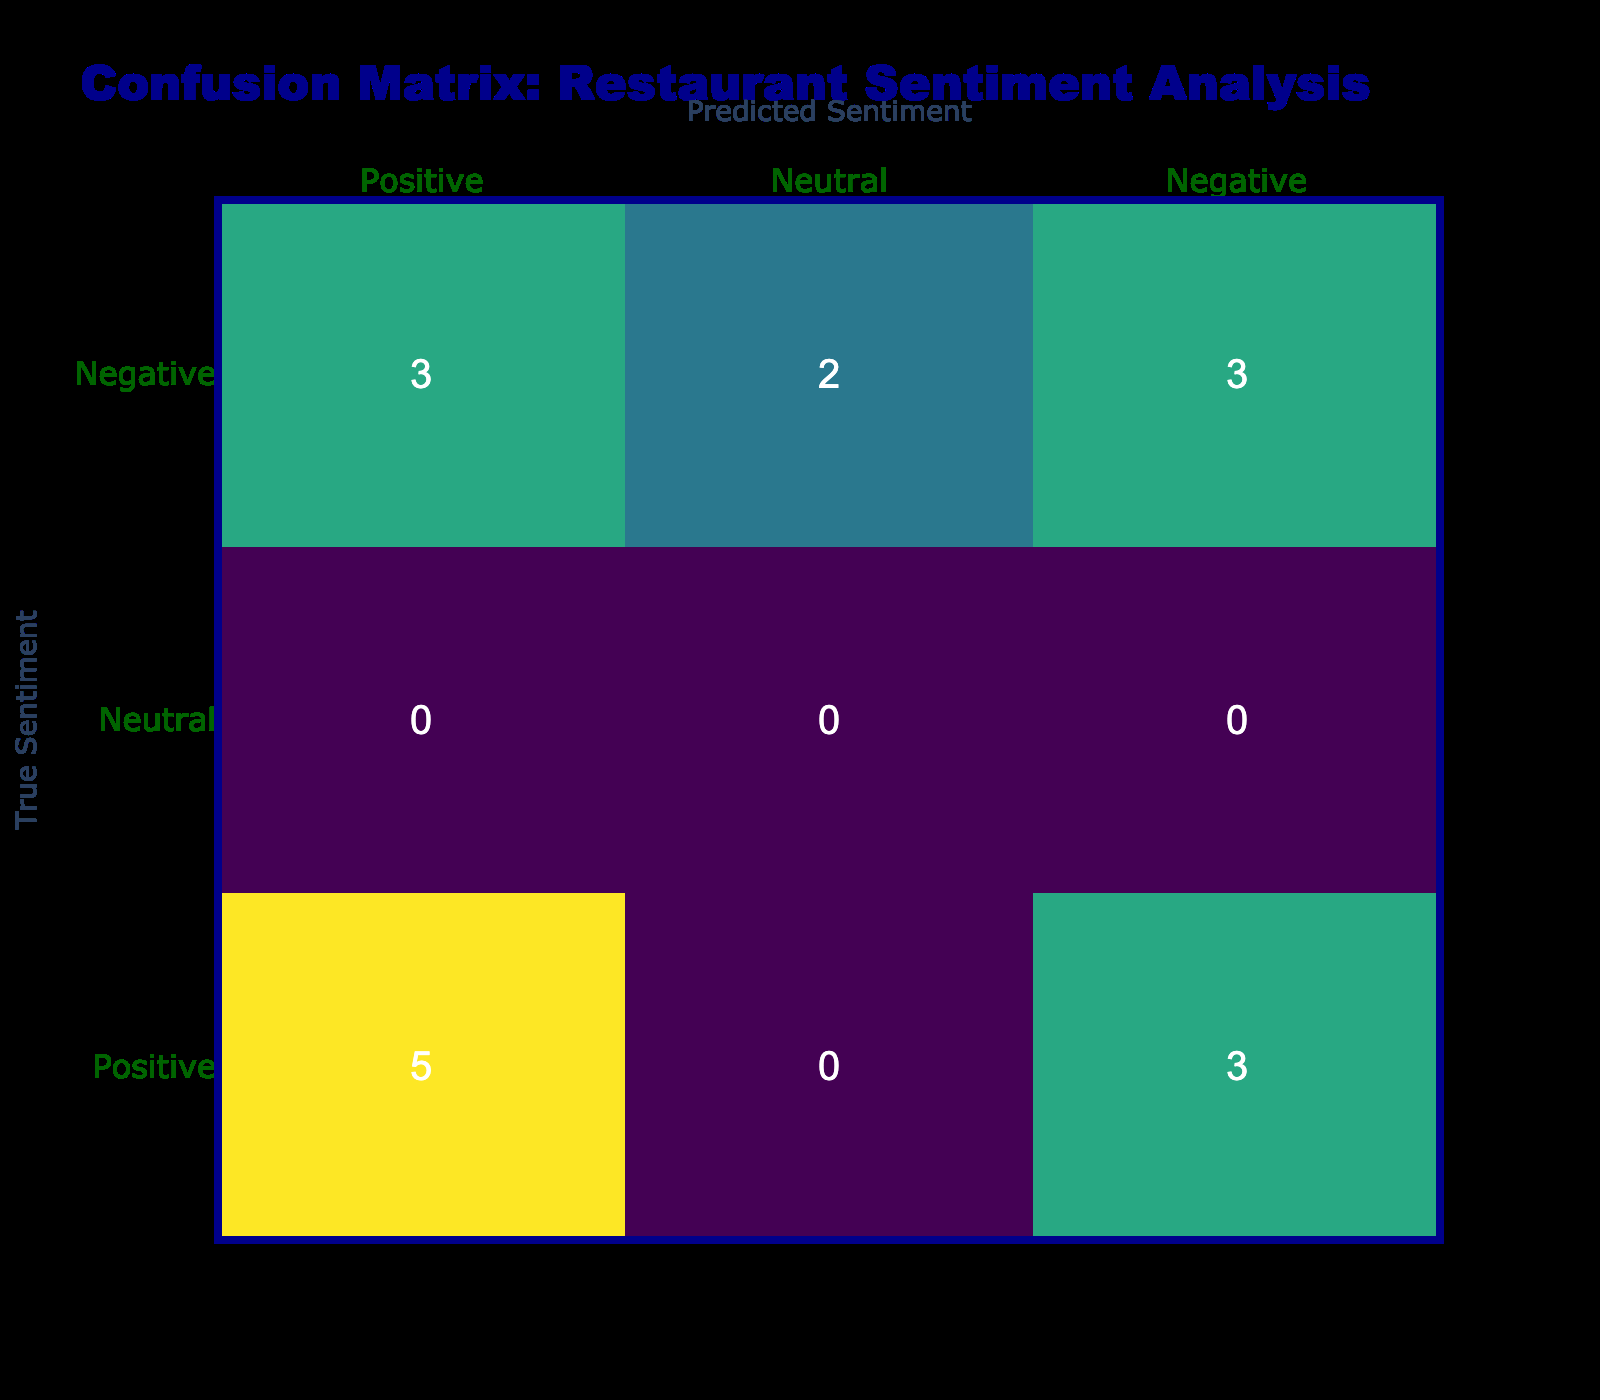What is the count of true positive sentiments predicted for Pasta Palace? In the confusion matrix, we look at the row for Pasta Palace (the true label). The positive sentiment count is found in the column for predicted positive sentiments. There are 5 instances where the sentiment for Pasta Palace was correctly predicted as positive.
Answer: 5 How many times was Burger Bonanza's sentiment incorrectly predicted as positive? For Burger Bonanza, we check the column where positive sentiments are predicted and look at the row for true negative sentiments. There are 3 instances (1 for Neutral and 2 for Negative) where Burger Bonanza was incorrectly predicted as positive.
Answer: 3 What is the total number of neutral sentiments predicted for both restaurants? To get the total number of neutral sentiments, we need to sum the instances in the neutral column for both restaurants. There are 2 instances for Pasta Palace and 3 instances for Burger Bonanza. Thus, total neutral predictions are 2 + 3 = 5.
Answer: 5 Is it true that Pasta Palace had more negative predictions than Burger Bonanza? We compare the counts in the negative predicted column for both restaurants. Pasta Palace has 3 negative predictions while Burger Bonanza has 2. Therefore, it is true that Pasta Palace had more negative predictions.
Answer: Yes How many total predictions were made for each restaurant? We can find this by summing the counts of the true sentiments for both restaurants. Pasta Palace has 6 true positive + 3 true negative + 3 true neutral = 12 total. Burger Bonanza has 3 true positive + 3 true negative + 3 true neutral = 9 total. Hence, Pasta Palace has 12 total predictions, and Burger Bonanza has 9.
Answer: 12 for Pasta Palace, 9 for Burger Bonanza How often was the sentiment for Pasta Palace correctly predicted as negative compared to Burger Bonanza? For Pasta Palace, the count of true negatives predicted is 0, while for Burger Bonanza, the count is also 2. Therefore, Pasta Palace had correct negative predictions 0 times, while Burger Bonanza had correct negative predictions 2 times, indicating Pasta Palace had fewer correct negative predictions.
Answer: Pasta Palace had 0, Burger Bonanza had 2 Which restaurant had a higher overall positive predicted sentiment? We can determine this by checking the positive predicted sentiment count for both. Pasta Palace has 5 positive predictions while Burger Bonanza has 2. Thus, Pasta Palace had a higher overall positive sentiment.
Answer: Pasta Palace 